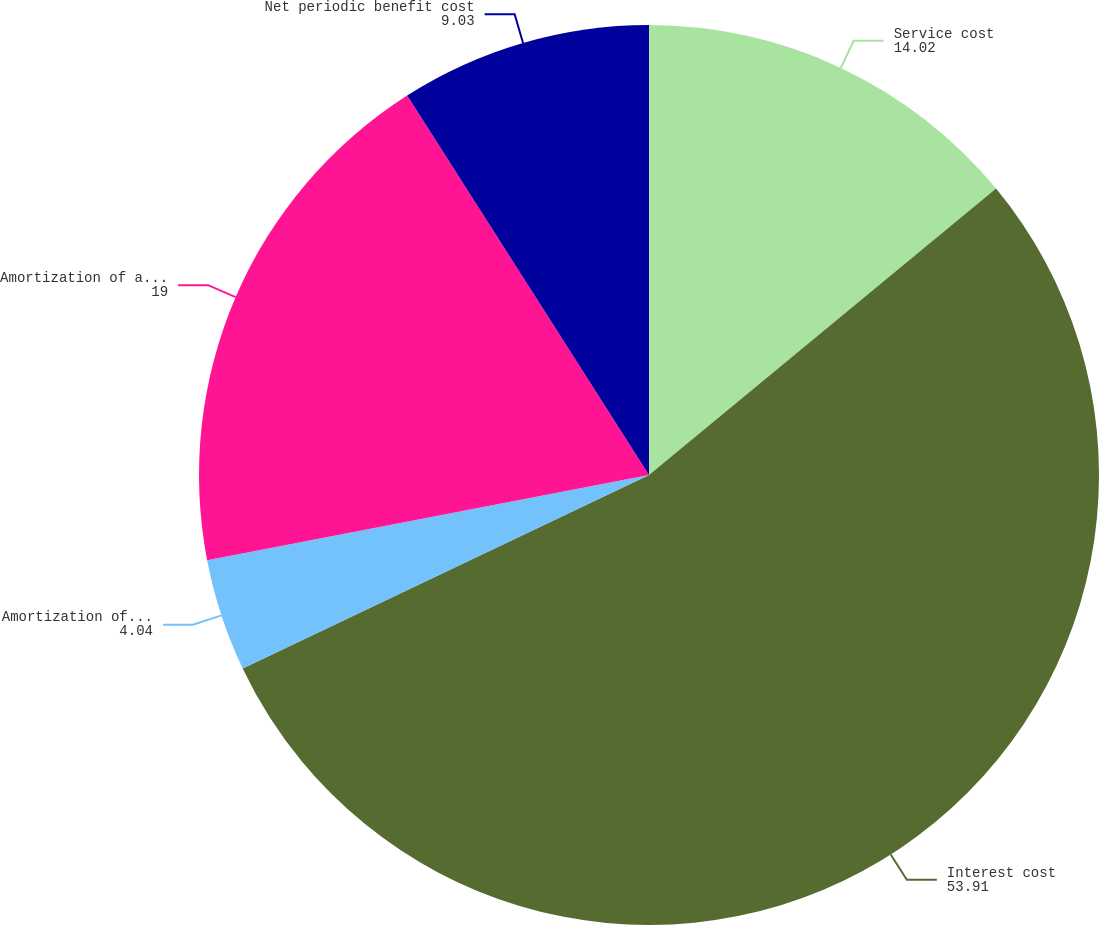Convert chart. <chart><loc_0><loc_0><loc_500><loc_500><pie_chart><fcel>Service cost<fcel>Interest cost<fcel>Amortization of prior service<fcel>Amortization of actuarial loss<fcel>Net periodic benefit cost<nl><fcel>14.02%<fcel>53.91%<fcel>4.04%<fcel>19.0%<fcel>9.03%<nl></chart> 